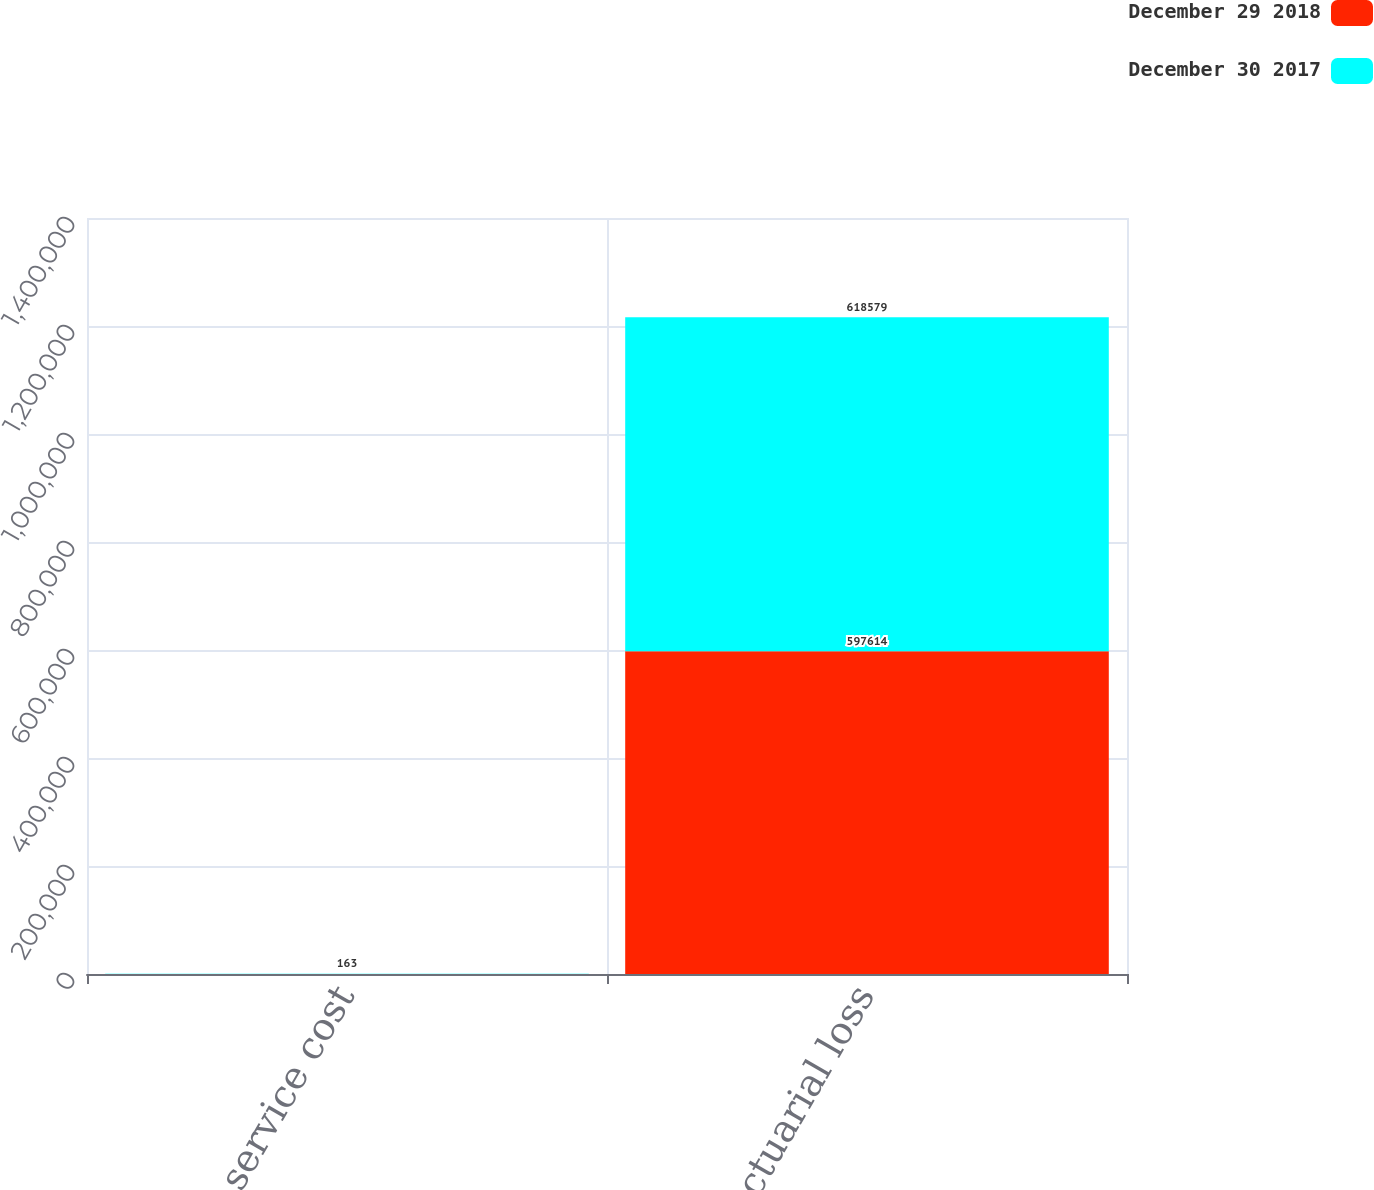Convert chart. <chart><loc_0><loc_0><loc_500><loc_500><stacked_bar_chart><ecel><fcel>Prior service cost<fcel>Actuarial loss<nl><fcel>December 29 2018<fcel>157<fcel>597614<nl><fcel>December 30 2017<fcel>163<fcel>618579<nl></chart> 